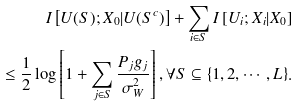Convert formula to latex. <formula><loc_0><loc_0><loc_500><loc_500>I \left [ U ( S ) ; X _ { 0 } | U ( S ^ { c } ) \right ] + \sum _ { i \in S } I \left [ U _ { i } ; X _ { i } | X _ { 0 } \right ] \\ \leq \frac { 1 } { 2 } \log \left [ 1 + \sum _ { j \in S } \frac { P _ { j } g _ { j } } { \sigma _ { W } ^ { 2 } } \right ] , \forall S \subseteq \{ 1 , 2 , \cdots , L \} .</formula> 